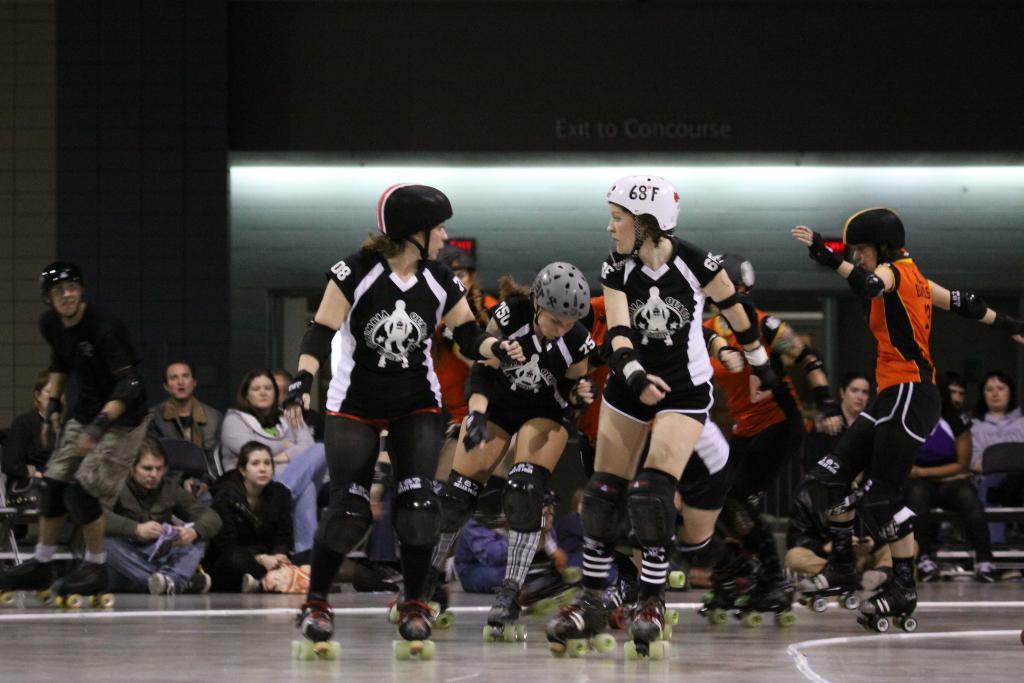How would you summarize this image in a sentence or two? In this image there are many people. In the foreground there are a few girls skating on the floor. They are wearing roller skates. In the background there are a few people sitting on the chairs and a few sitting on the floor. In the extreme background there is a wall. There is text on the wall. 